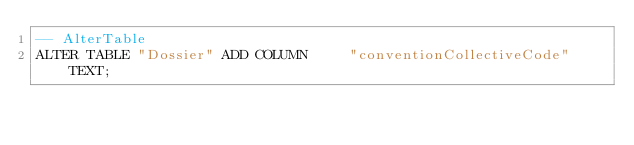Convert code to text. <code><loc_0><loc_0><loc_500><loc_500><_SQL_>-- AlterTable
ALTER TABLE "Dossier" ADD COLUMN     "conventionCollectiveCode" TEXT;
</code> 